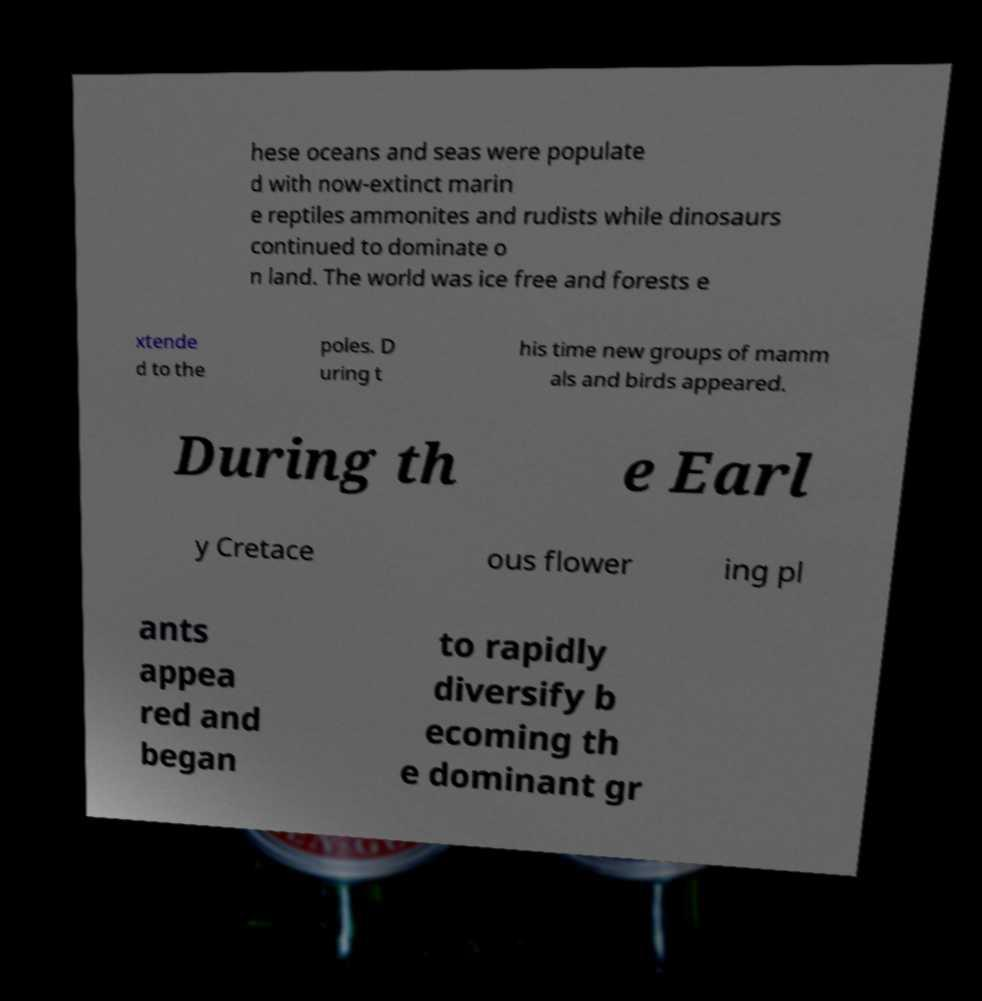Please read and relay the text visible in this image. What does it say? hese oceans and seas were populate d with now-extinct marin e reptiles ammonites and rudists while dinosaurs continued to dominate o n land. The world was ice free and forests e xtende d to the poles. D uring t his time new groups of mamm als and birds appeared. During th e Earl y Cretace ous flower ing pl ants appea red and began to rapidly diversify b ecoming th e dominant gr 